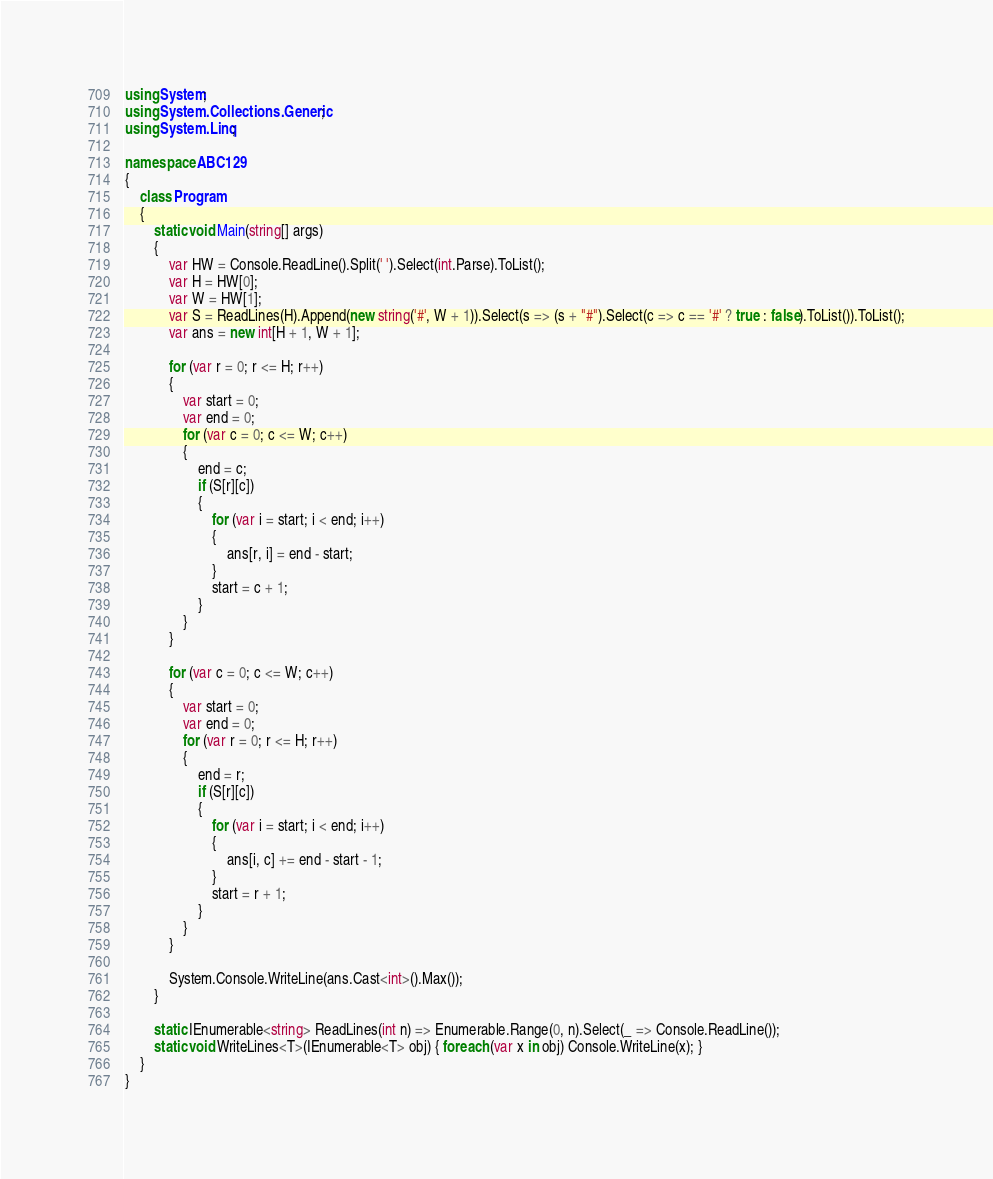<code> <loc_0><loc_0><loc_500><loc_500><_C#_>using System;
using System.Collections.Generic;
using System.Linq;

namespace ABC129
{
	class Program
	{
		static void Main(string[] args)
		{
			var HW = Console.ReadLine().Split(' ').Select(int.Parse).ToList();
			var H = HW[0];
			var W = HW[1];
			var S = ReadLines(H).Append(new string('#', W + 1)).Select(s => (s + "#").Select(c => c == '#' ? true : false).ToList()).ToList();
			var ans = new int[H + 1, W + 1];

			for (var r = 0; r <= H; r++)
			{
				var start = 0;
				var end = 0;
				for (var c = 0; c <= W; c++)
				{
					end = c;
					if (S[r][c])
					{
						for (var i = start; i < end; i++)
						{
							ans[r, i] = end - start;
						}
						start = c + 1;
					}
				}
			}

			for (var c = 0; c <= W; c++)
			{
				var start = 0;
				var end = 0;
				for (var r = 0; r <= H; r++)
				{
					end = r;
					if (S[r][c])
					{
						for (var i = start; i < end; i++)
						{
							ans[i, c] += end - start - 1;
						}
						start = r + 1;
					}
				}
			}

			System.Console.WriteLine(ans.Cast<int>().Max());
		}

		static IEnumerable<string> ReadLines(int n) => Enumerable.Range(0, n).Select(_ => Console.ReadLine());
		static void WriteLines<T>(IEnumerable<T> obj) { foreach (var x in obj) Console.WriteLine(x); }
	}
}
</code> 